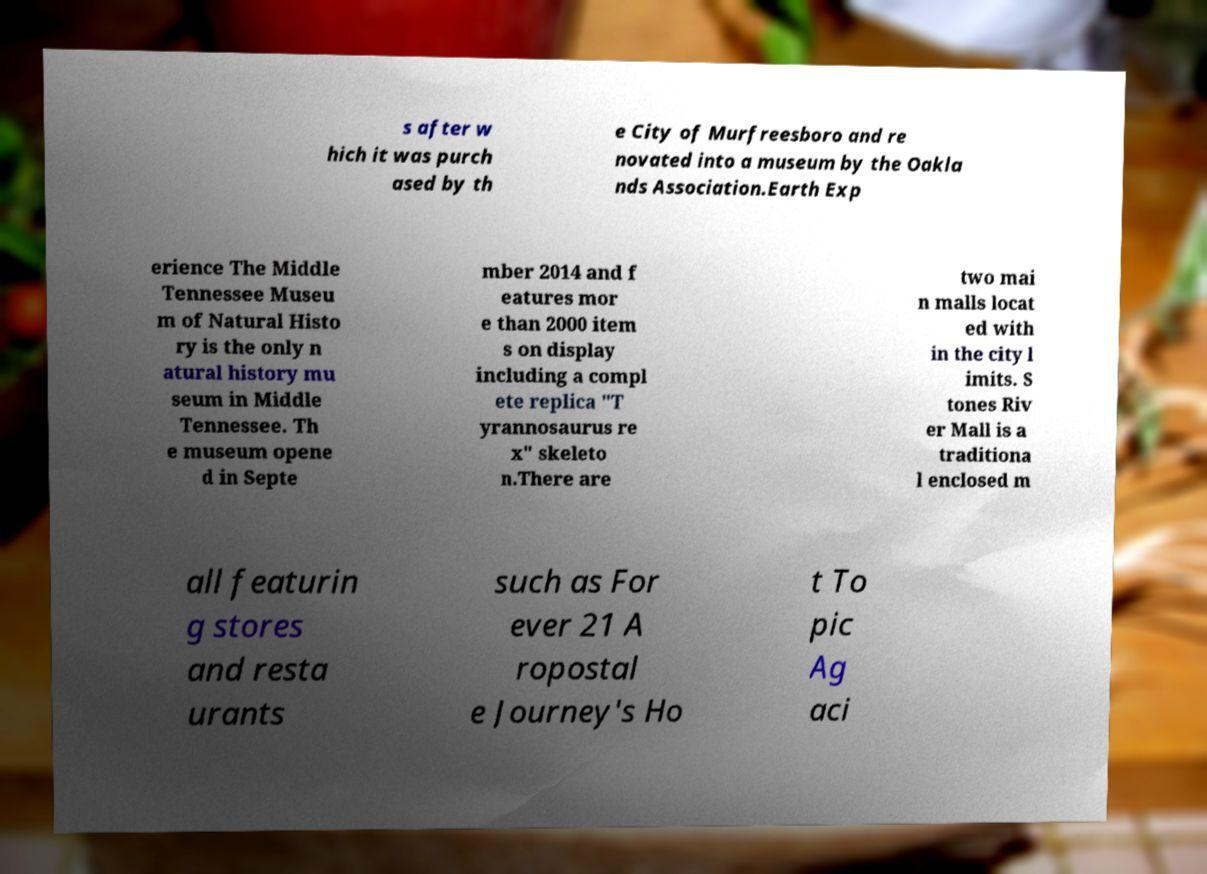I need the written content from this picture converted into text. Can you do that? s after w hich it was purch ased by th e City of Murfreesboro and re novated into a museum by the Oakla nds Association.Earth Exp erience The Middle Tennessee Museu m of Natural Histo ry is the only n atural history mu seum in Middle Tennessee. Th e museum opene d in Septe mber 2014 and f eatures mor e than 2000 item s on display including a compl ete replica "T yrannosaurus re x" skeleto n.There are two mai n malls locat ed with in the city l imits. S tones Riv er Mall is a traditiona l enclosed m all featurin g stores and resta urants such as For ever 21 A ropostal e Journey's Ho t To pic Ag aci 